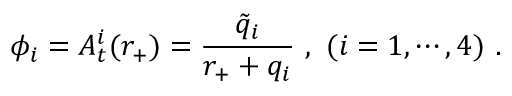Convert formula to latex. <formula><loc_0><loc_0><loc_500><loc_500>\phi _ { i } = A _ { t } ^ { i } ( r _ { + } ) = { \frac { \tilde { q } _ { i } } { r _ { + } + q _ { i } } } \ , \ ( i = 1 , \cdots , 4 ) \ .</formula> 